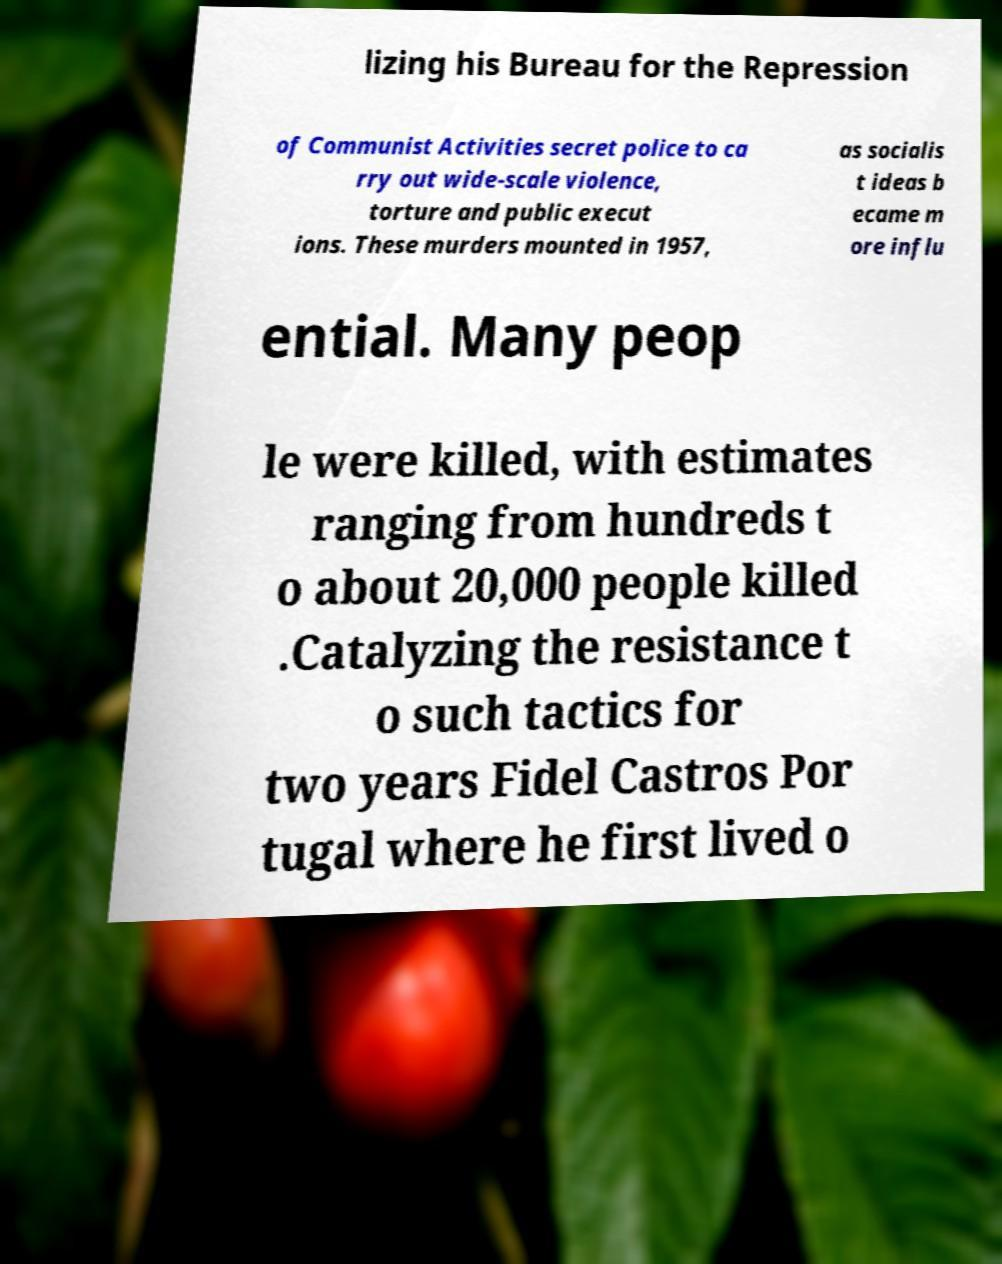Can you read and provide the text displayed in the image?This photo seems to have some interesting text. Can you extract and type it out for me? lizing his Bureau for the Repression of Communist Activities secret police to ca rry out wide-scale violence, torture and public execut ions. These murders mounted in 1957, as socialis t ideas b ecame m ore influ ential. Many peop le were killed, with estimates ranging from hundreds t o about 20,000 people killed .Catalyzing the resistance t o such tactics for two years Fidel Castros Por tugal where he first lived o 